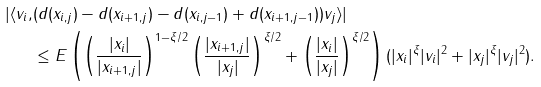Convert formula to latex. <formula><loc_0><loc_0><loc_500><loc_500>| \langle v _ { i } , & ( d ( x _ { i , j } ) - d ( x _ { i + 1 , j } ) - d ( x _ { i , j - 1 } ) + d ( x _ { i + 1 , j - 1 } ) ) v _ { j } \rangle | \\ & \leq E \left ( \left ( \frac { | x _ { i } | } { | x _ { i + 1 , j } | } \right ) ^ { 1 - \xi / 2 } \left ( \frac { | x _ { i + 1 , j } | } { | x _ { j } | } \right ) ^ { \xi / 2 } + \left ( \frac { | x _ { i } | } { | x _ { j } | } \right ) ^ { \xi / 2 } \right ) ( | x _ { i } | ^ { \xi } | v _ { i } | ^ { 2 } + | x _ { j } | ^ { \xi } | v _ { j } | ^ { 2 } ) .</formula> 